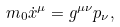Convert formula to latex. <formula><loc_0><loc_0><loc_500><loc_500>m _ { 0 } \dot { x } ^ { \mu } = g ^ { \mu \nu } p _ { \nu } ,</formula> 